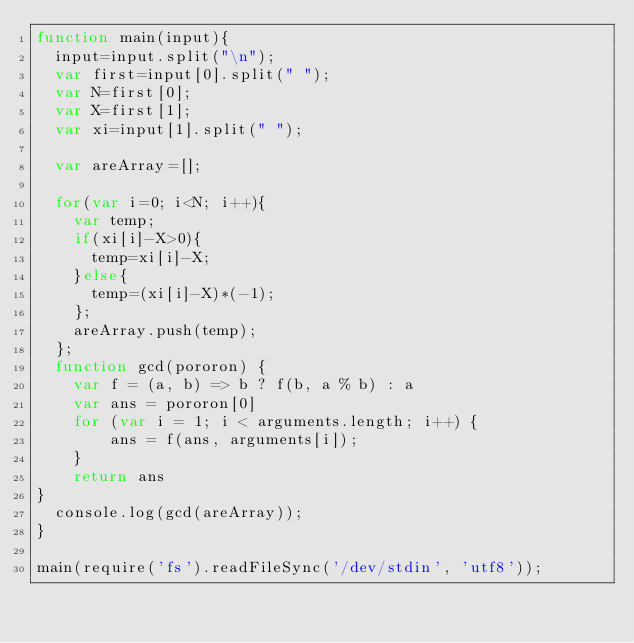<code> <loc_0><loc_0><loc_500><loc_500><_JavaScript_>function main(input){
  input=input.split("\n");
  var first=input[0].split(" ");
  var N=first[0];
  var X=first[1];
  var xi=input[1].split(" ");
  
  var areArray=[];

  for(var i=0; i<N; i++){
    var temp;
    if(xi[i]-X>0){
      temp=xi[i]-X;
    }else{
      temp=(xi[i]-X)*(-1);
    };
    areArray.push(temp);
  };
  function gcd(pororon) {
    var f = (a, b) => b ? f(b, a % b) : a
    var ans = pororon[0]
    for (var i = 1; i < arguments.length; i++) {
        ans = f(ans, arguments[i]); 
    }
    return ans 
}
  console.log(gcd(areArray));
}

main(require('fs').readFileSync('/dev/stdin', 'utf8'));


</code> 